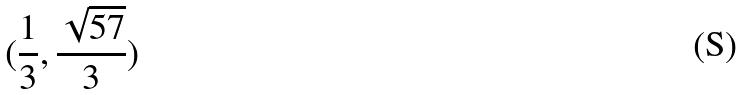Convert formula to latex. <formula><loc_0><loc_0><loc_500><loc_500>( \frac { 1 } { 3 } , \frac { \sqrt { 5 7 } } { 3 } )</formula> 